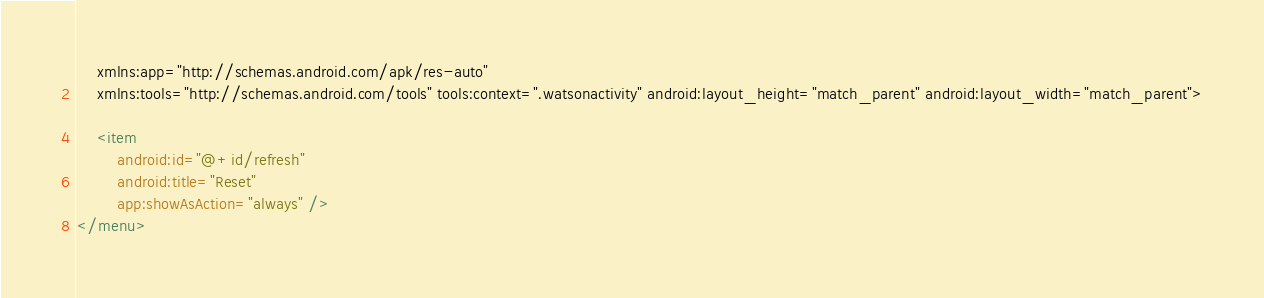<code> <loc_0><loc_0><loc_500><loc_500><_XML_>    xmlns:app="http://schemas.android.com/apk/res-auto"
    xmlns:tools="http://schemas.android.com/tools" tools:context=".watsonactivity" android:layout_height="match_parent" android:layout_width="match_parent">

    <item
        android:id="@+id/refresh"
        android:title="Reset"
        app:showAsAction="always" />
</menu></code> 